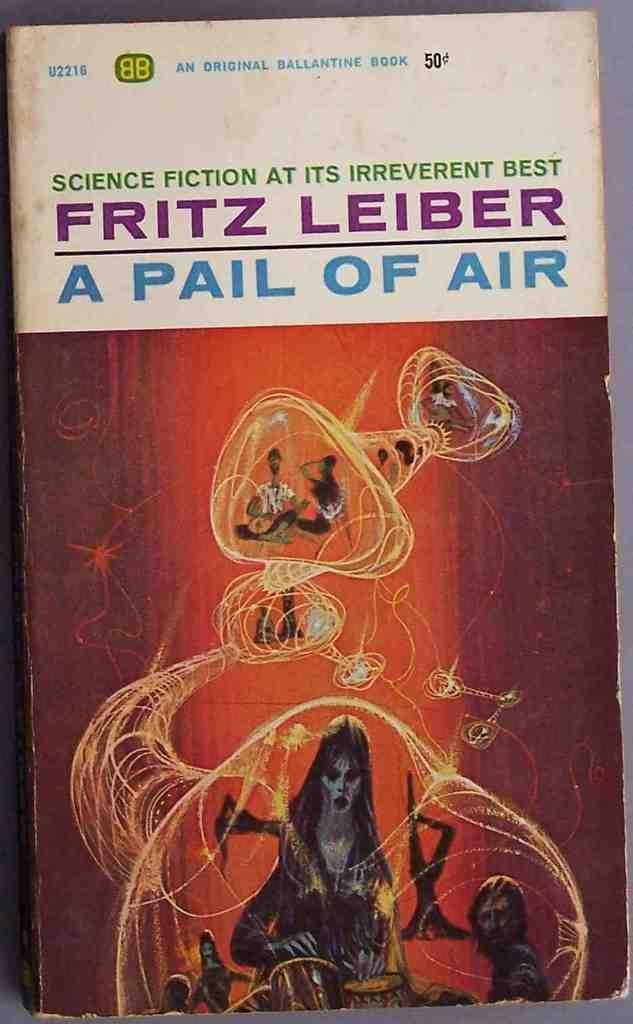Provide a one-sentence caption for the provided image. A science fiction novel by Fritz Leiber has a worn cover. 